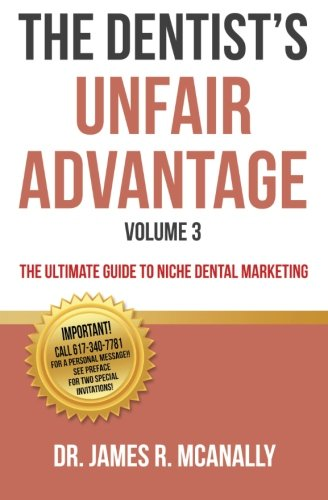Is this a sci-fi book? No, this book is purely informational and pertains to niche dental marketing, not science fiction. 